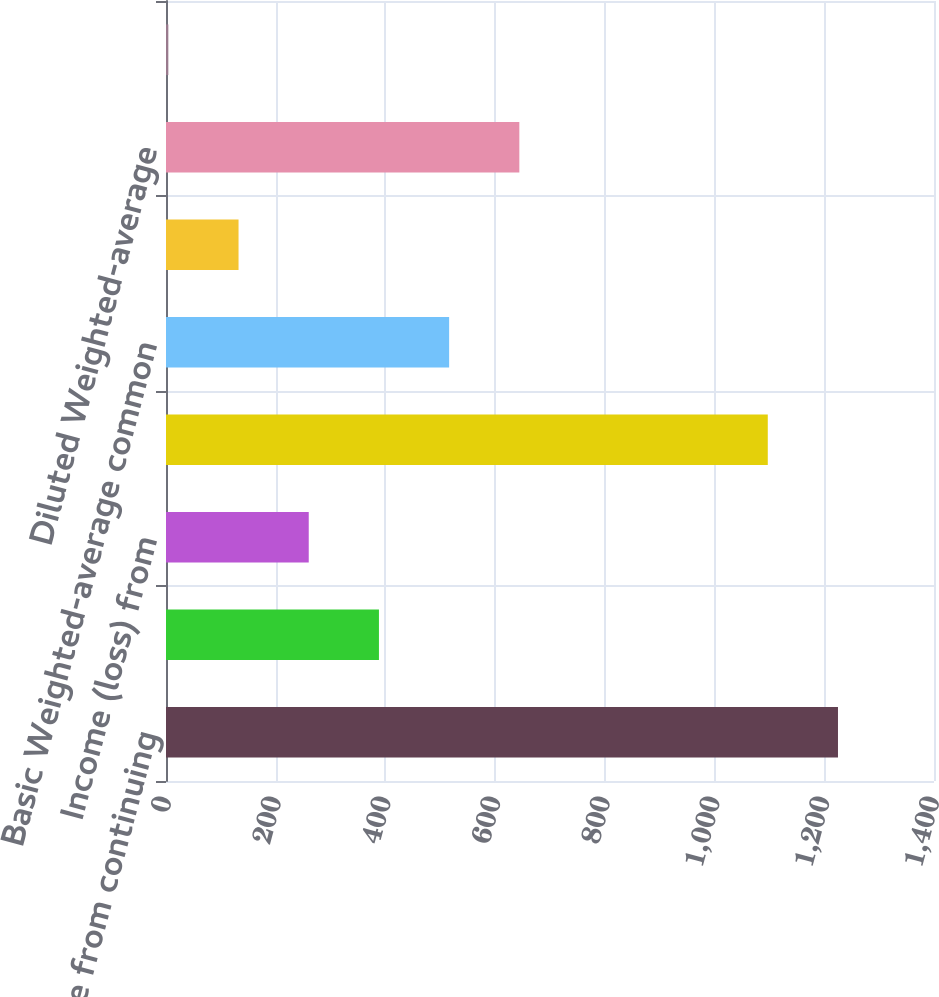<chart> <loc_0><loc_0><loc_500><loc_500><bar_chart><fcel>Income from continuing<fcel>Less Net income (loss)<fcel>Income (loss) from<fcel>Net income attributable to<fcel>Basic Weighted-average common<fcel>and other share-based awards<fcel>Diluted Weighted-average<fcel>Net income<nl><fcel>1224.97<fcel>388.17<fcel>260.2<fcel>1097<fcel>516.14<fcel>132.23<fcel>644.11<fcel>4.26<nl></chart> 